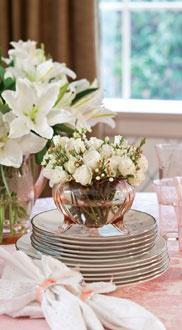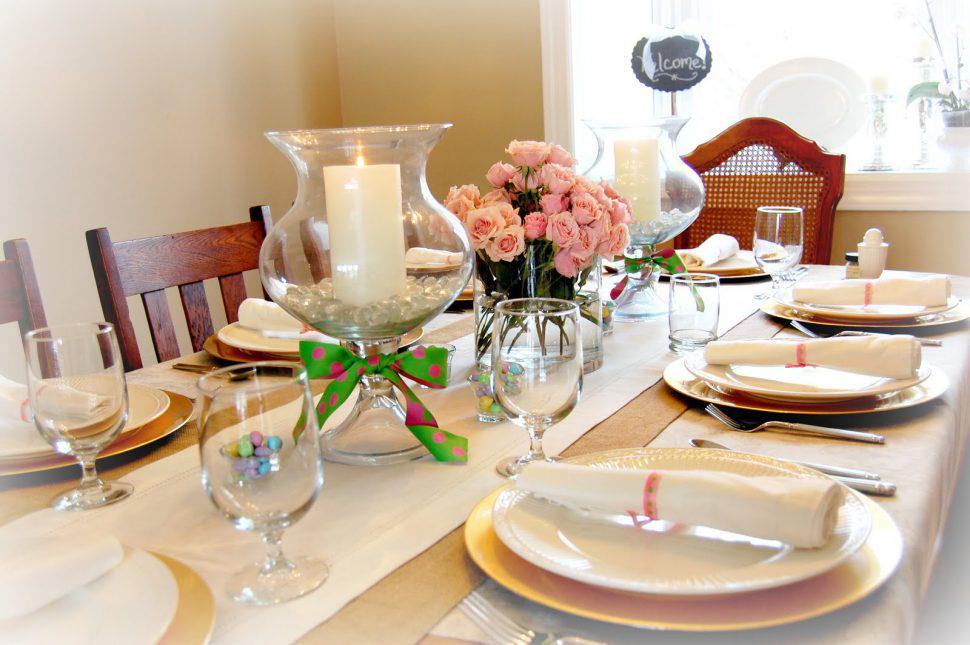The first image is the image on the left, the second image is the image on the right. Examine the images to the left and right. Is the description "there are lit candles in glass vases" accurate? Answer yes or no. Yes. 